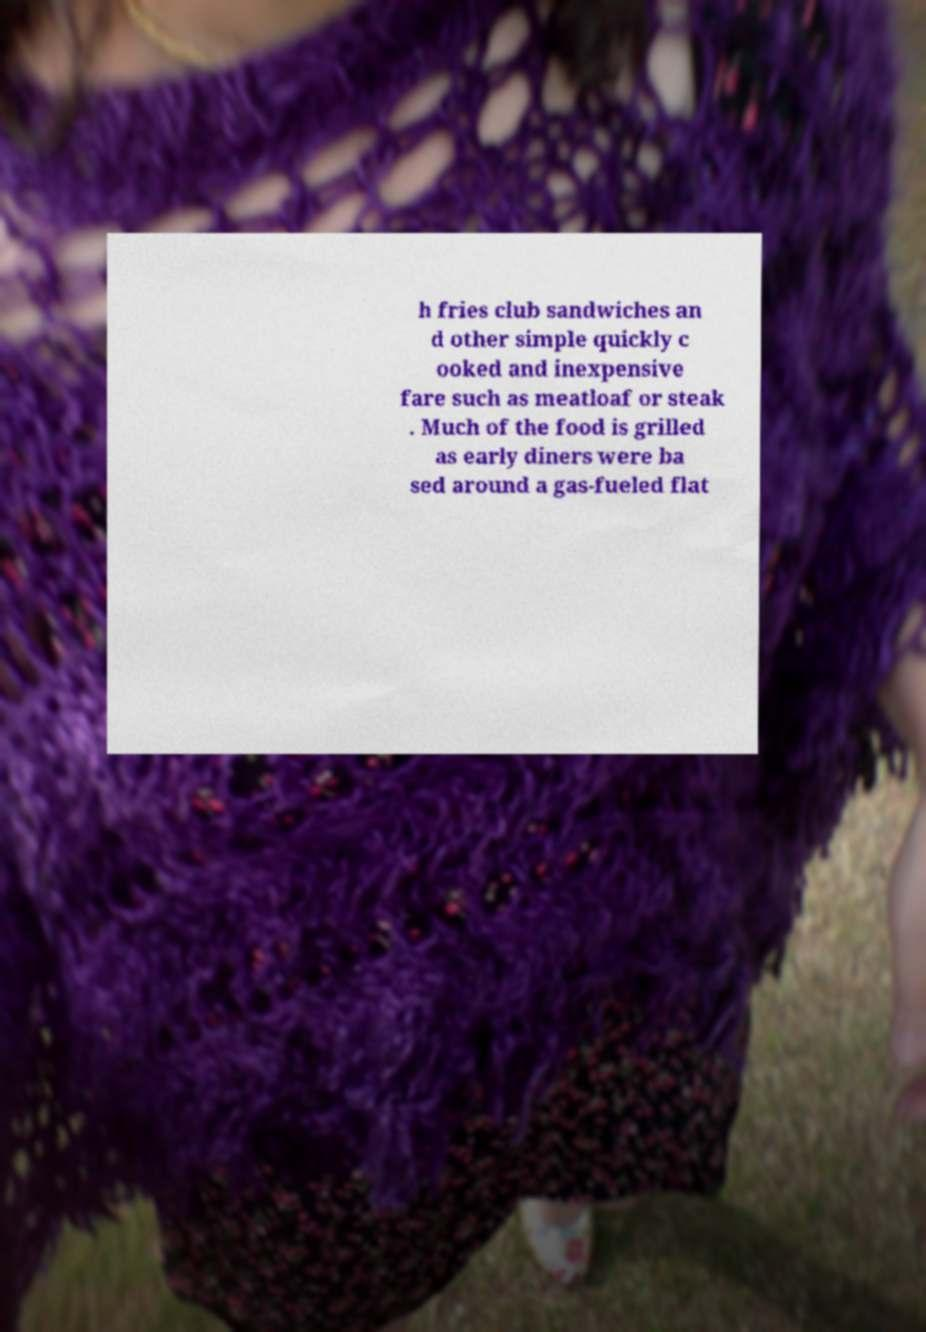There's text embedded in this image that I need extracted. Can you transcribe it verbatim? h fries club sandwiches an d other simple quickly c ooked and inexpensive fare such as meatloaf or steak . Much of the food is grilled as early diners were ba sed around a gas-fueled flat 